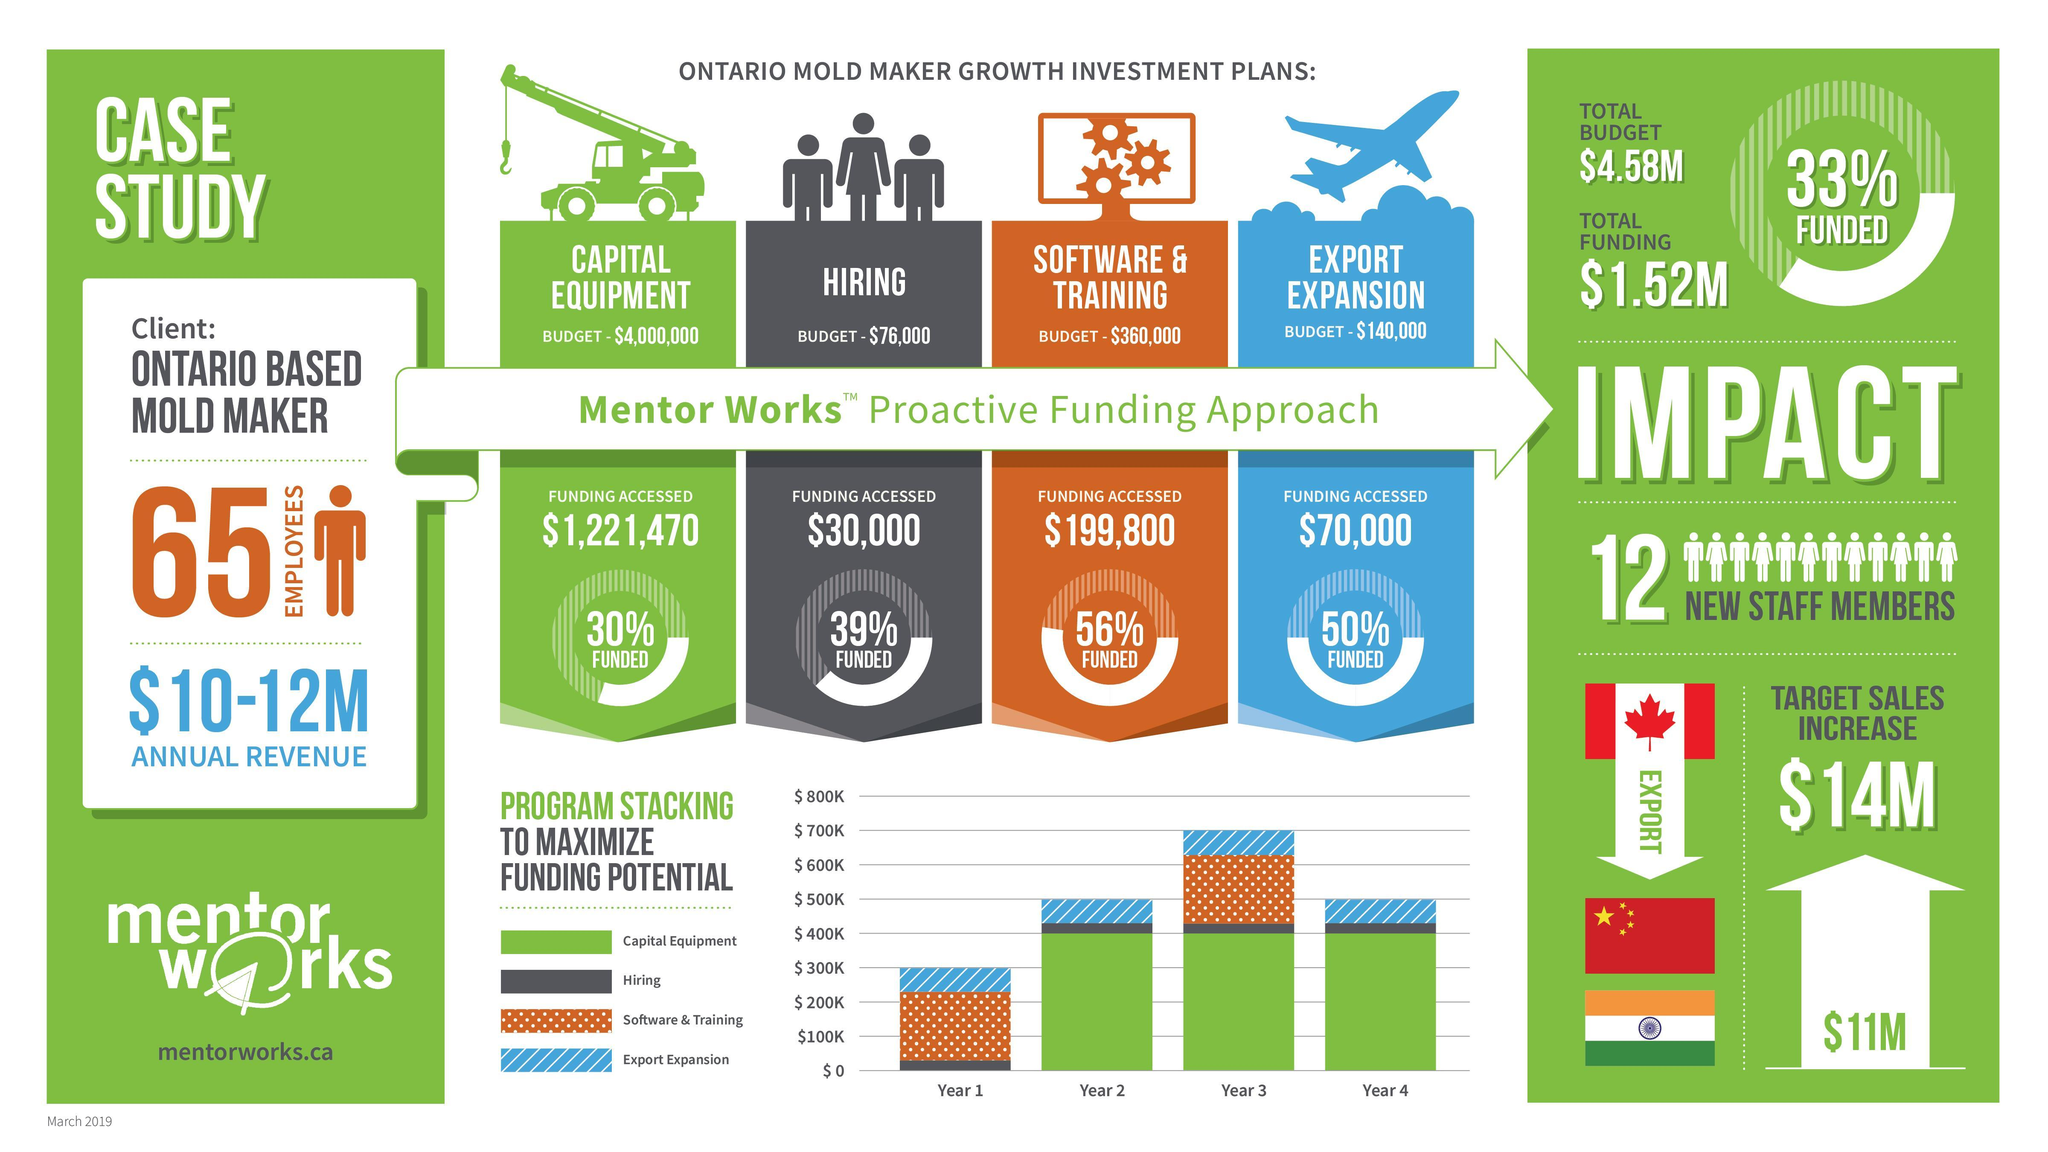What is the budget of Ontario based mold maker in software & training?
Answer the question with a short phrase. $360,000 What is the budget of Ontario based mold maker in export expnasion? $140,000 What percentage of funding is accessed by the Ontario based mold maker in software & training? 56% What is the budget of Ontario based mold maker for hiring employees? $76,000 What percentage of funding is accessed by the Ontario based mold maker in capital equipment? 30% 